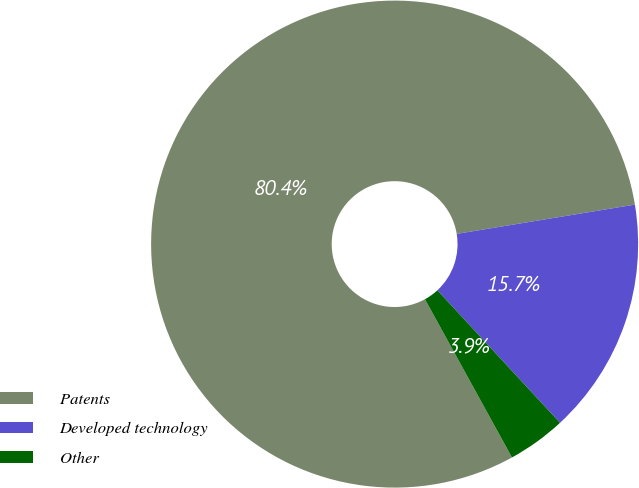Convert chart. <chart><loc_0><loc_0><loc_500><loc_500><pie_chart><fcel>Patents<fcel>Developed technology<fcel>Other<nl><fcel>80.41%<fcel>15.71%<fcel>3.88%<nl></chart> 